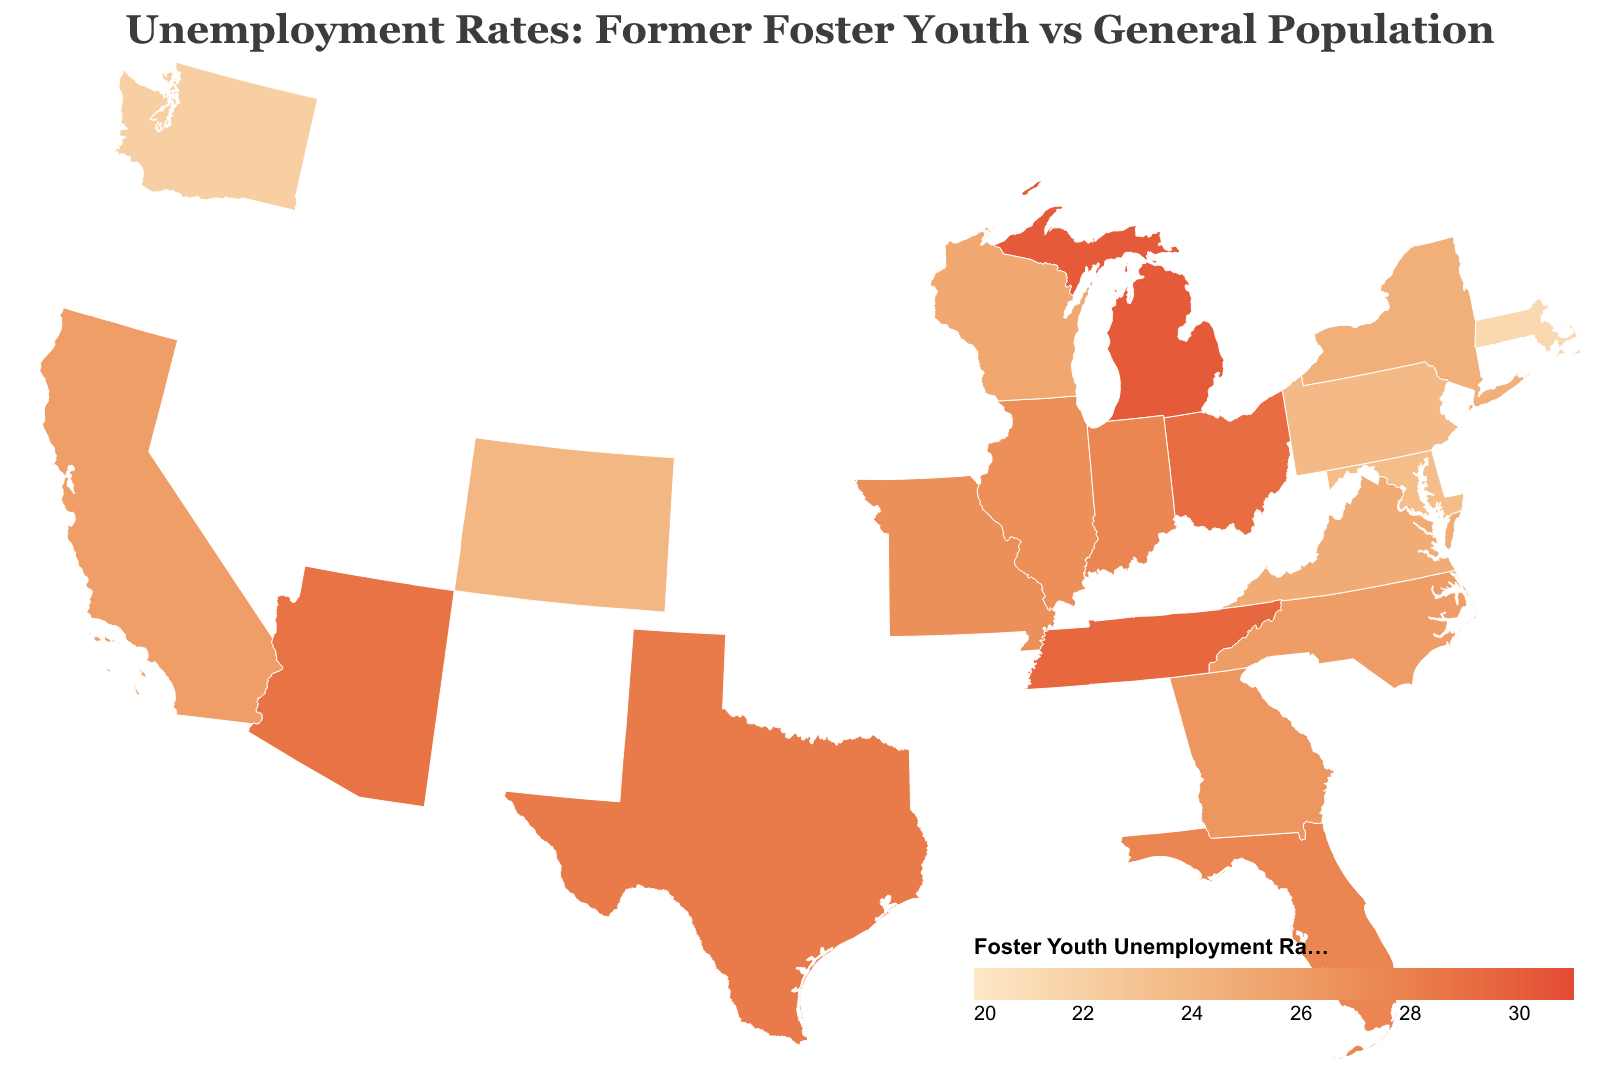Which state has the highest unemployment rate among former foster youth? By looking at the color gradient ranging from light to dark, identify the darkest colored state which corresponds to the highest value. Michigan has the highest reported rate at 30.2%.
Answer: Michigan What is the title of the plot? The title is displayed at the top of the plot in a larger, distinct font. It reads: "Unemployment Rates: Former Foster Youth vs General Population".
Answer: "Unemployment Rates: Former Foster Youth vs General Population" How does the unemployment rate of former foster youth in California compare to the general population in the same state? By examining the tooltip for California, the Foster Youth Unemployment Rate is 25.8% while the General Population Unemployment Rate is 4.2%. Subtracting these rates gives a difference of 21.6 percentage points.
Answer: 21.6 percentage points higher What is the average unemployment rate among former foster youth across all states provided? Adding up all the Foster Youth Unemployment Rate values and dividing by the number of states (20): (25.8 + 28.3 + 27.5 + 24.6 + 26.9 + 23.7 + 29.1 + 30.2 + 26.4 + 25.9 + 22.1 + 21.3 + 24.8 + 28.7 + 27.6 + 29.4 + 26.8 + 23.5 + 25.2 + 24.0) / 20 = 26.1995
Answer: 26.2% Which state shows the smallest gap between the unemployment rate of former foster youth and the general population? The smallest gap is found by calculating the absolute difference for each state and identifying the minimum value. Massachusetts has a Foster Youth Unemployment Rate of 21.3% and a General Population Unemployment Rate of 3.5%, yielding a gap of 17.8 percentage points, which is the smallest.
Answer: Massachusetts Is there any state where the unemployment rate of the general population is higher than 5%? By reviewing the General Population Unemployment Rate for all states listed in the tooltips, none have a rate exceeding 5%.
Answer: No What color range is used to represent the Foster Youth Unemployment Rate on the map? The color range starts from light shades and goes to dark shades, representing values from 20% to 31%. The color gradient ranges from light peach (#fee8c8) to dark crimson (#e34a33).
Answer: From light peach to dark crimson Compare the unemployment rates of former foster youth in Texas and Florida. Which state has a higher rate? Looking at the values, Texas has a Foster Youth Unemployment Rate of 28.3%, while Florida has a rate of 27.5%.
Answer: Texas Which state has the lowest unemployment rate among former foster youth? By identifying the lightest color state on the map or checking the values, Massachusetts has the lowest rate at 21.3%.
Answer: Massachusetts 